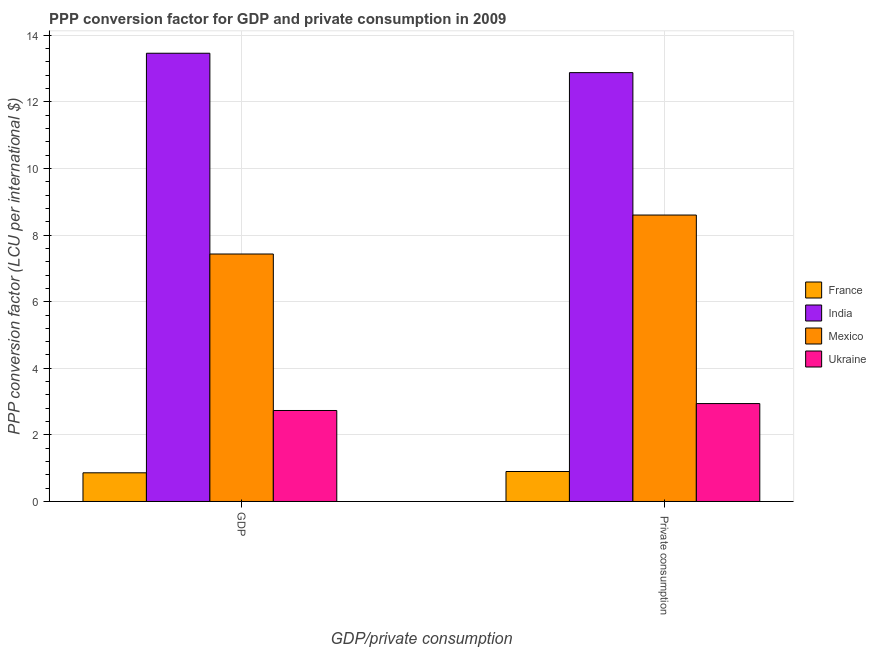How many different coloured bars are there?
Provide a succinct answer. 4. How many groups of bars are there?
Make the answer very short. 2. Are the number of bars per tick equal to the number of legend labels?
Give a very brief answer. Yes. Are the number of bars on each tick of the X-axis equal?
Offer a terse response. Yes. What is the label of the 2nd group of bars from the left?
Offer a terse response.  Private consumption. What is the ppp conversion factor for private consumption in India?
Your answer should be very brief. 12.88. Across all countries, what is the maximum ppp conversion factor for private consumption?
Your answer should be compact. 12.88. Across all countries, what is the minimum ppp conversion factor for private consumption?
Give a very brief answer. 0.9. In which country was the ppp conversion factor for gdp maximum?
Ensure brevity in your answer.  India. In which country was the ppp conversion factor for gdp minimum?
Offer a terse response. France. What is the total ppp conversion factor for gdp in the graph?
Keep it short and to the point. 24.49. What is the difference between the ppp conversion factor for gdp in India and that in Mexico?
Make the answer very short. 6.03. What is the difference between the ppp conversion factor for private consumption in France and the ppp conversion factor for gdp in Mexico?
Give a very brief answer. -6.53. What is the average ppp conversion factor for private consumption per country?
Keep it short and to the point. 6.33. What is the difference between the ppp conversion factor for private consumption and ppp conversion factor for gdp in India?
Your response must be concise. -0.58. What is the ratio of the ppp conversion factor for private consumption in India to that in Mexico?
Your response must be concise. 1.5. In how many countries, is the ppp conversion factor for gdp greater than the average ppp conversion factor for gdp taken over all countries?
Your response must be concise. 2. What does the 2nd bar from the right in GDP represents?
Your answer should be very brief. Mexico. Are all the bars in the graph horizontal?
Offer a very short reply. No. Are the values on the major ticks of Y-axis written in scientific E-notation?
Your answer should be very brief. No. Does the graph contain any zero values?
Offer a very short reply. No. Does the graph contain grids?
Give a very brief answer. Yes. How many legend labels are there?
Make the answer very short. 4. How are the legend labels stacked?
Ensure brevity in your answer.  Vertical. What is the title of the graph?
Keep it short and to the point. PPP conversion factor for GDP and private consumption in 2009. Does "Libya" appear as one of the legend labels in the graph?
Provide a succinct answer. No. What is the label or title of the X-axis?
Offer a terse response. GDP/private consumption. What is the label or title of the Y-axis?
Your answer should be very brief. PPP conversion factor (LCU per international $). What is the PPP conversion factor (LCU per international $) of France in GDP?
Give a very brief answer. 0.86. What is the PPP conversion factor (LCU per international $) in India in GDP?
Your answer should be compact. 13.46. What is the PPP conversion factor (LCU per international $) in Mexico in GDP?
Offer a very short reply. 7.43. What is the PPP conversion factor (LCU per international $) of Ukraine in GDP?
Give a very brief answer. 2.73. What is the PPP conversion factor (LCU per international $) in France in  Private consumption?
Provide a short and direct response. 0.9. What is the PPP conversion factor (LCU per international $) in India in  Private consumption?
Keep it short and to the point. 12.88. What is the PPP conversion factor (LCU per international $) in Mexico in  Private consumption?
Ensure brevity in your answer.  8.6. What is the PPP conversion factor (LCU per international $) of Ukraine in  Private consumption?
Offer a very short reply. 2.94. Across all GDP/private consumption, what is the maximum PPP conversion factor (LCU per international $) of France?
Your answer should be compact. 0.9. Across all GDP/private consumption, what is the maximum PPP conversion factor (LCU per international $) in India?
Give a very brief answer. 13.46. Across all GDP/private consumption, what is the maximum PPP conversion factor (LCU per international $) in Mexico?
Your answer should be compact. 8.6. Across all GDP/private consumption, what is the maximum PPP conversion factor (LCU per international $) of Ukraine?
Make the answer very short. 2.94. Across all GDP/private consumption, what is the minimum PPP conversion factor (LCU per international $) in France?
Keep it short and to the point. 0.86. Across all GDP/private consumption, what is the minimum PPP conversion factor (LCU per international $) in India?
Ensure brevity in your answer.  12.88. Across all GDP/private consumption, what is the minimum PPP conversion factor (LCU per international $) in Mexico?
Offer a very short reply. 7.43. Across all GDP/private consumption, what is the minimum PPP conversion factor (LCU per international $) in Ukraine?
Offer a very short reply. 2.73. What is the total PPP conversion factor (LCU per international $) in France in the graph?
Make the answer very short. 1.76. What is the total PPP conversion factor (LCU per international $) of India in the graph?
Keep it short and to the point. 26.34. What is the total PPP conversion factor (LCU per international $) of Mexico in the graph?
Offer a very short reply. 16.03. What is the total PPP conversion factor (LCU per international $) of Ukraine in the graph?
Provide a short and direct response. 5.67. What is the difference between the PPP conversion factor (LCU per international $) of France in GDP and that in  Private consumption?
Keep it short and to the point. -0.04. What is the difference between the PPP conversion factor (LCU per international $) of India in GDP and that in  Private consumption?
Provide a succinct answer. 0.58. What is the difference between the PPP conversion factor (LCU per international $) of Mexico in GDP and that in  Private consumption?
Your answer should be compact. -1.17. What is the difference between the PPP conversion factor (LCU per international $) in Ukraine in GDP and that in  Private consumption?
Ensure brevity in your answer.  -0.21. What is the difference between the PPP conversion factor (LCU per international $) of France in GDP and the PPP conversion factor (LCU per international $) of India in  Private consumption?
Ensure brevity in your answer.  -12.02. What is the difference between the PPP conversion factor (LCU per international $) in France in GDP and the PPP conversion factor (LCU per international $) in Mexico in  Private consumption?
Provide a short and direct response. -7.74. What is the difference between the PPP conversion factor (LCU per international $) in France in GDP and the PPP conversion factor (LCU per international $) in Ukraine in  Private consumption?
Ensure brevity in your answer.  -2.08. What is the difference between the PPP conversion factor (LCU per international $) of India in GDP and the PPP conversion factor (LCU per international $) of Mexico in  Private consumption?
Your answer should be compact. 4.86. What is the difference between the PPP conversion factor (LCU per international $) of India in GDP and the PPP conversion factor (LCU per international $) of Ukraine in  Private consumption?
Your response must be concise. 10.52. What is the difference between the PPP conversion factor (LCU per international $) in Mexico in GDP and the PPP conversion factor (LCU per international $) in Ukraine in  Private consumption?
Your answer should be very brief. 4.49. What is the average PPP conversion factor (LCU per international $) of France per GDP/private consumption?
Your response must be concise. 0.88. What is the average PPP conversion factor (LCU per international $) in India per GDP/private consumption?
Provide a short and direct response. 13.17. What is the average PPP conversion factor (LCU per international $) of Mexico per GDP/private consumption?
Give a very brief answer. 8.02. What is the average PPP conversion factor (LCU per international $) of Ukraine per GDP/private consumption?
Make the answer very short. 2.84. What is the difference between the PPP conversion factor (LCU per international $) of France and PPP conversion factor (LCU per international $) of India in GDP?
Provide a short and direct response. -12.6. What is the difference between the PPP conversion factor (LCU per international $) of France and PPP conversion factor (LCU per international $) of Mexico in GDP?
Offer a terse response. -6.57. What is the difference between the PPP conversion factor (LCU per international $) of France and PPP conversion factor (LCU per international $) of Ukraine in GDP?
Ensure brevity in your answer.  -1.87. What is the difference between the PPP conversion factor (LCU per international $) of India and PPP conversion factor (LCU per international $) of Mexico in GDP?
Offer a very short reply. 6.03. What is the difference between the PPP conversion factor (LCU per international $) of India and PPP conversion factor (LCU per international $) of Ukraine in GDP?
Give a very brief answer. 10.73. What is the difference between the PPP conversion factor (LCU per international $) of Mexico and PPP conversion factor (LCU per international $) of Ukraine in GDP?
Provide a succinct answer. 4.7. What is the difference between the PPP conversion factor (LCU per international $) in France and PPP conversion factor (LCU per international $) in India in  Private consumption?
Provide a short and direct response. -11.98. What is the difference between the PPP conversion factor (LCU per international $) of France and PPP conversion factor (LCU per international $) of Mexico in  Private consumption?
Your answer should be compact. -7.7. What is the difference between the PPP conversion factor (LCU per international $) of France and PPP conversion factor (LCU per international $) of Ukraine in  Private consumption?
Offer a terse response. -2.04. What is the difference between the PPP conversion factor (LCU per international $) of India and PPP conversion factor (LCU per international $) of Mexico in  Private consumption?
Offer a very short reply. 4.28. What is the difference between the PPP conversion factor (LCU per international $) in India and PPP conversion factor (LCU per international $) in Ukraine in  Private consumption?
Offer a very short reply. 9.94. What is the difference between the PPP conversion factor (LCU per international $) in Mexico and PPP conversion factor (LCU per international $) in Ukraine in  Private consumption?
Provide a succinct answer. 5.66. What is the ratio of the PPP conversion factor (LCU per international $) in France in GDP to that in  Private consumption?
Keep it short and to the point. 0.96. What is the ratio of the PPP conversion factor (LCU per international $) in India in GDP to that in  Private consumption?
Ensure brevity in your answer.  1.05. What is the ratio of the PPP conversion factor (LCU per international $) in Mexico in GDP to that in  Private consumption?
Offer a very short reply. 0.86. What is the ratio of the PPP conversion factor (LCU per international $) of Ukraine in GDP to that in  Private consumption?
Offer a very short reply. 0.93. What is the difference between the highest and the second highest PPP conversion factor (LCU per international $) in France?
Your response must be concise. 0.04. What is the difference between the highest and the second highest PPP conversion factor (LCU per international $) in India?
Ensure brevity in your answer.  0.58. What is the difference between the highest and the second highest PPP conversion factor (LCU per international $) of Mexico?
Your response must be concise. 1.17. What is the difference between the highest and the second highest PPP conversion factor (LCU per international $) in Ukraine?
Make the answer very short. 0.21. What is the difference between the highest and the lowest PPP conversion factor (LCU per international $) of France?
Give a very brief answer. 0.04. What is the difference between the highest and the lowest PPP conversion factor (LCU per international $) in India?
Provide a short and direct response. 0.58. What is the difference between the highest and the lowest PPP conversion factor (LCU per international $) in Mexico?
Provide a short and direct response. 1.17. What is the difference between the highest and the lowest PPP conversion factor (LCU per international $) in Ukraine?
Offer a terse response. 0.21. 